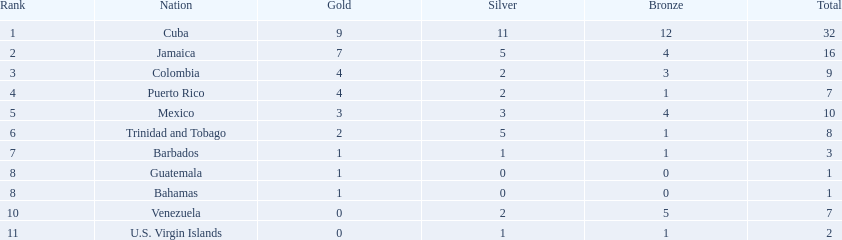Which teams achieved four gold medals? Colombia, Puerto Rico. Out of these, which team had just one bronze medal? Puerto Rico. 